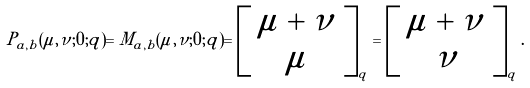<formula> <loc_0><loc_0><loc_500><loc_500>P _ { a , b } ( \mu , \nu ; 0 ; q ) = M _ { a , b } ( \mu , \nu ; 0 ; q ) = \left [ \begin{array} { c } { \mu + \nu } \\ { \mu } \end{array} \right ] _ { q } = \left [ \begin{array} { c } { \mu + \nu } \\ { \nu } \end{array} \right ] _ { q } .</formula> 